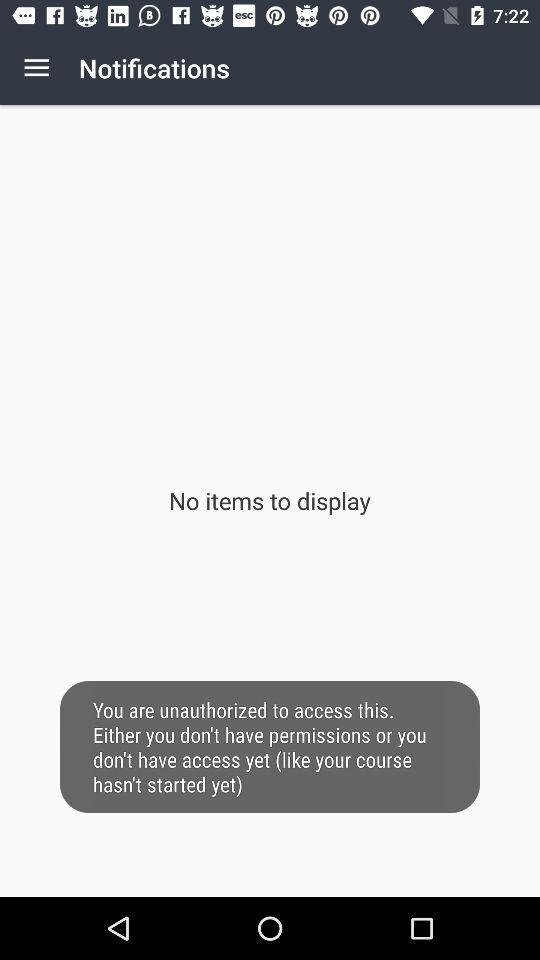How many items are displayed? There are no items to display. 